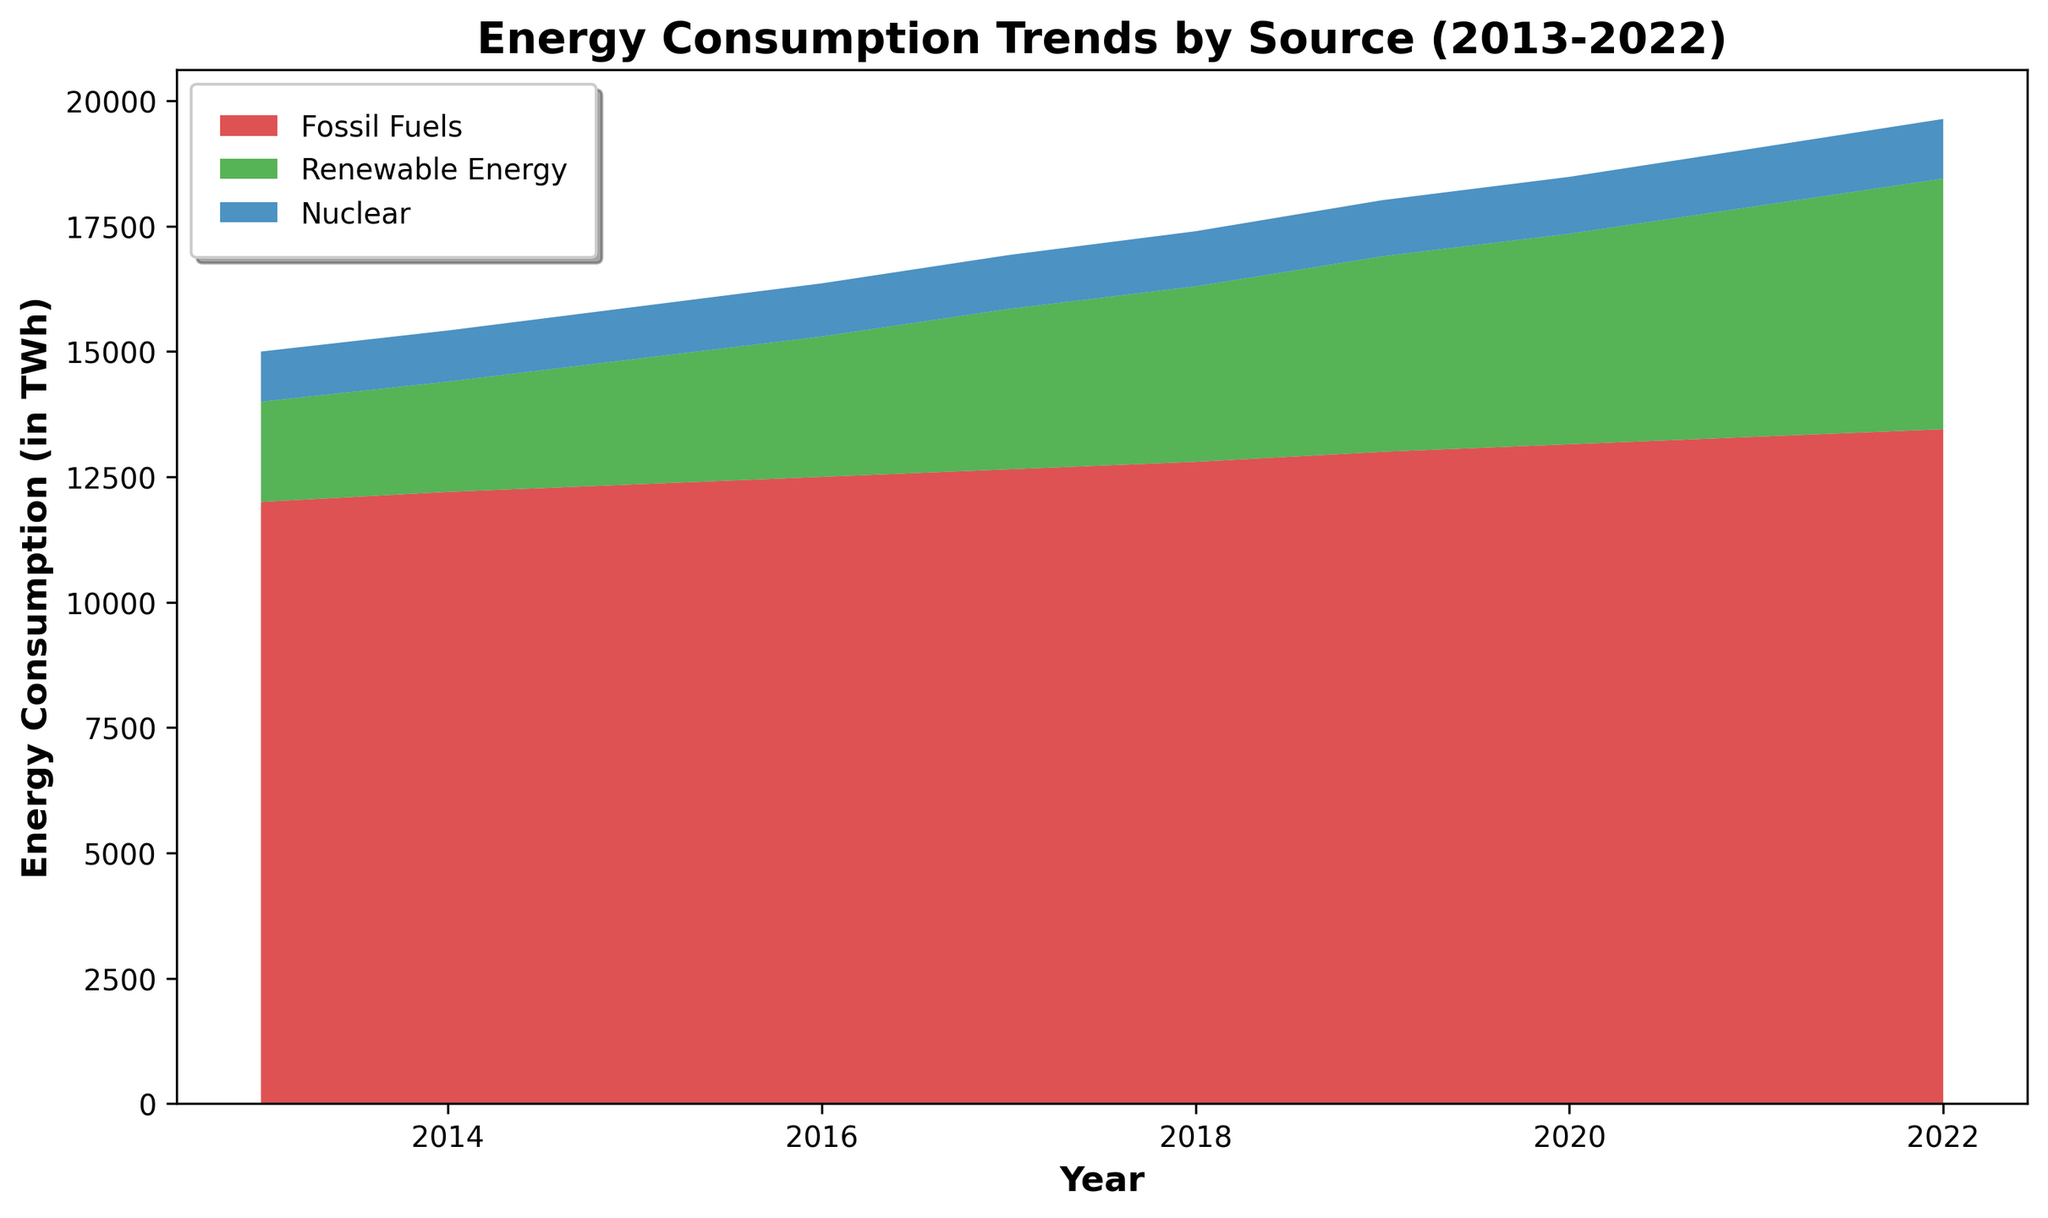What's the total energy consumption from Fossil Fuels and Nuclear in 2016? Sum the energy consumption values for Fossil Fuels and Nuclear in the year 2016: 12500 + 1060 = 13560 TWh
Answer: 13560 TWh Which energy source shows the largest growth in consumption from 2013 to 2022? Compare the consumption values from 2013 to 2022 for each energy source. Fossil Fuels: 13450 - 12000 = 1450 TWh, Renewable Energy: 5000 - 2000 = 3000 TWh, Nuclear: 1190 - 1000 = 190 TWh. Renewable Energy has the largest growth of 3000 TWh
Answer: Renewable Energy What year did Renewable Energy consumption exceed 4000 TWh? Check the data for Renewable Energy starting from 2013. Year by year: Renewable Energy exceeds 4000 TWh in 2020.
Answer: 2020 In which year was the total energy consumption (sum of all sources) the highest? Calculate the total energy consumption for each year. The year 2022 has the highest: 13450 + 5000 + 1190 = 19640 TWh
Answer: 2022 By how much did Nuclear energy consumption increase from 2019 to 2022? Calculate the difference in Nuclear consumption between 2022 and 2019: 1190 - 1120 = 70 TWh
Answer: 70 TWh What's the average annual increase in Renewable Energy consumption from 2013 to 2022? Calculate the total increase and divide by the number of years: (5000 - 2000) / (2022 - 2013) = 3000 / 9 ≈ 333.33 TWh per year
Answer: 333.33 TWh per year In 2018, which energy source had the least consumption, and what was its value? Compare the values for 2018: Fossil Fuels: 12800 TWh, Renewable Energy: 3500 TWh, Nuclear: 1100 TWh. The Nuclear source had the least consumption at 1100 TWh
Answer: Nuclear, 1100 TWh How does the trend of Fossil Fuels compare to the trend of Renewable Energy over the decade? Assess the overall trend: Fossil Fuels steadily increased from 12000 TWh to 13450 TWh (slow growth), whereas Renewable Energy showed a more rapid increase from 2000 TWh to 5000 TWh.
Answer: Fossil Fuels increased slowly, Renewable Energy increased rapidly What is the combined energy consumption of Fossil Fuels and Renewable Energy in 2015? Add the consumption values for both sources in 2015: 12350 (Fossil Fuels) + 2500 (Renewable Energy) = 14850 TWh
Answer: 14850 TWh 